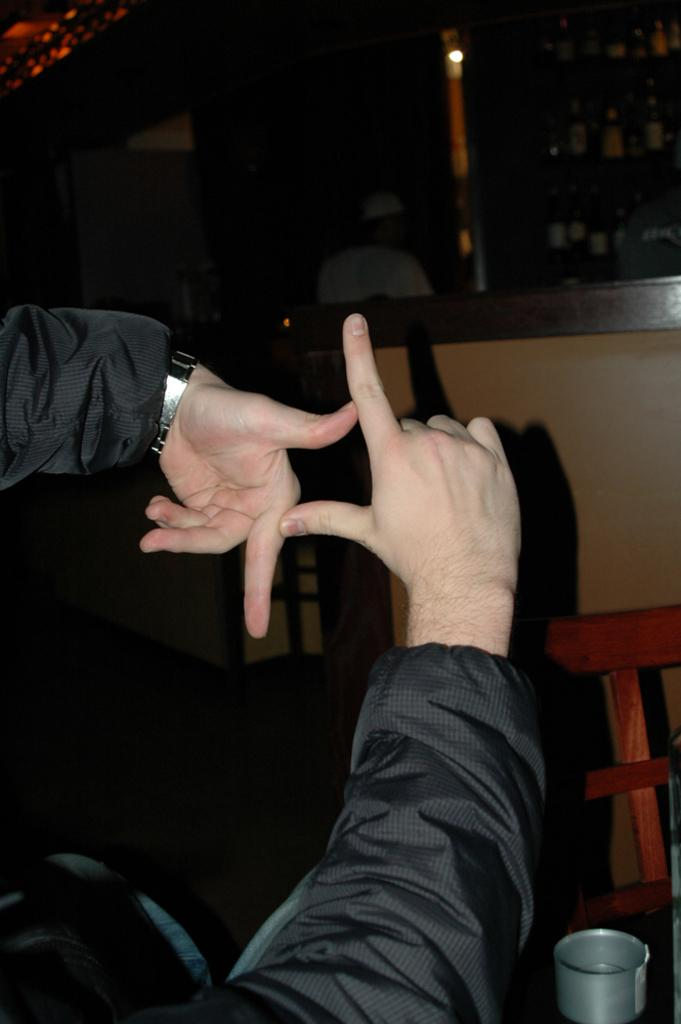What body part is visible in the image? There are human hands in the image. What type of furniture is present in the image? There is a chair in the image. What object is made of metal in the image? There is a tin in the image. What type of structure surrounds the scene in the image? There are walls in the image. What object can be used for personal grooming in the image? There is a mirror in the image. How does the cactus feel pain in the image? There is no cactus present in the image, so it cannot feel pain. What type of light source is illuminating the scene in the image? The provided facts do not mention any light source, so it cannot be determined from the image. 